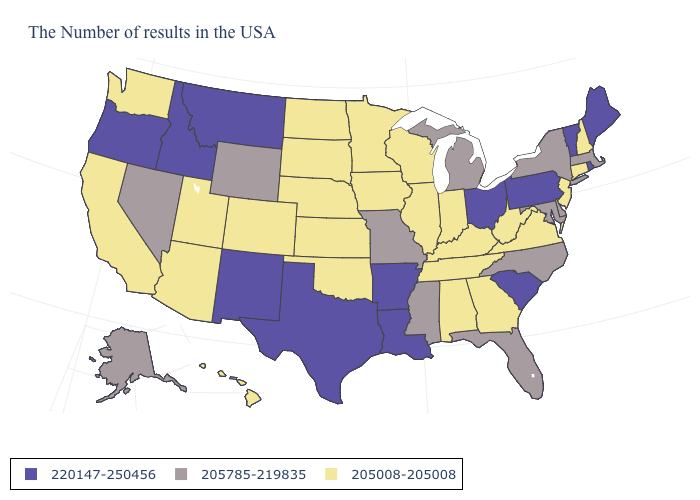What is the lowest value in the West?
Short answer required. 205008-205008. How many symbols are there in the legend?
Write a very short answer. 3. Which states have the highest value in the USA?
Keep it brief. Maine, Rhode Island, Vermont, Pennsylvania, South Carolina, Ohio, Louisiana, Arkansas, Texas, New Mexico, Montana, Idaho, Oregon. Does the first symbol in the legend represent the smallest category?
Be succinct. No. What is the value of Missouri?
Answer briefly. 205785-219835. Which states have the lowest value in the USA?
Answer briefly. New Hampshire, Connecticut, New Jersey, Virginia, West Virginia, Georgia, Kentucky, Indiana, Alabama, Tennessee, Wisconsin, Illinois, Minnesota, Iowa, Kansas, Nebraska, Oklahoma, South Dakota, North Dakota, Colorado, Utah, Arizona, California, Washington, Hawaii. What is the lowest value in the Northeast?
Answer briefly. 205008-205008. Is the legend a continuous bar?
Concise answer only. No. What is the value of New Mexico?
Quick response, please. 220147-250456. What is the value of Michigan?
Quick response, please. 205785-219835. Does Nebraska have a lower value than New Hampshire?
Write a very short answer. No. Among the states that border Alabama , does Tennessee have the highest value?
Be succinct. No. What is the value of Ohio?
Write a very short answer. 220147-250456. 